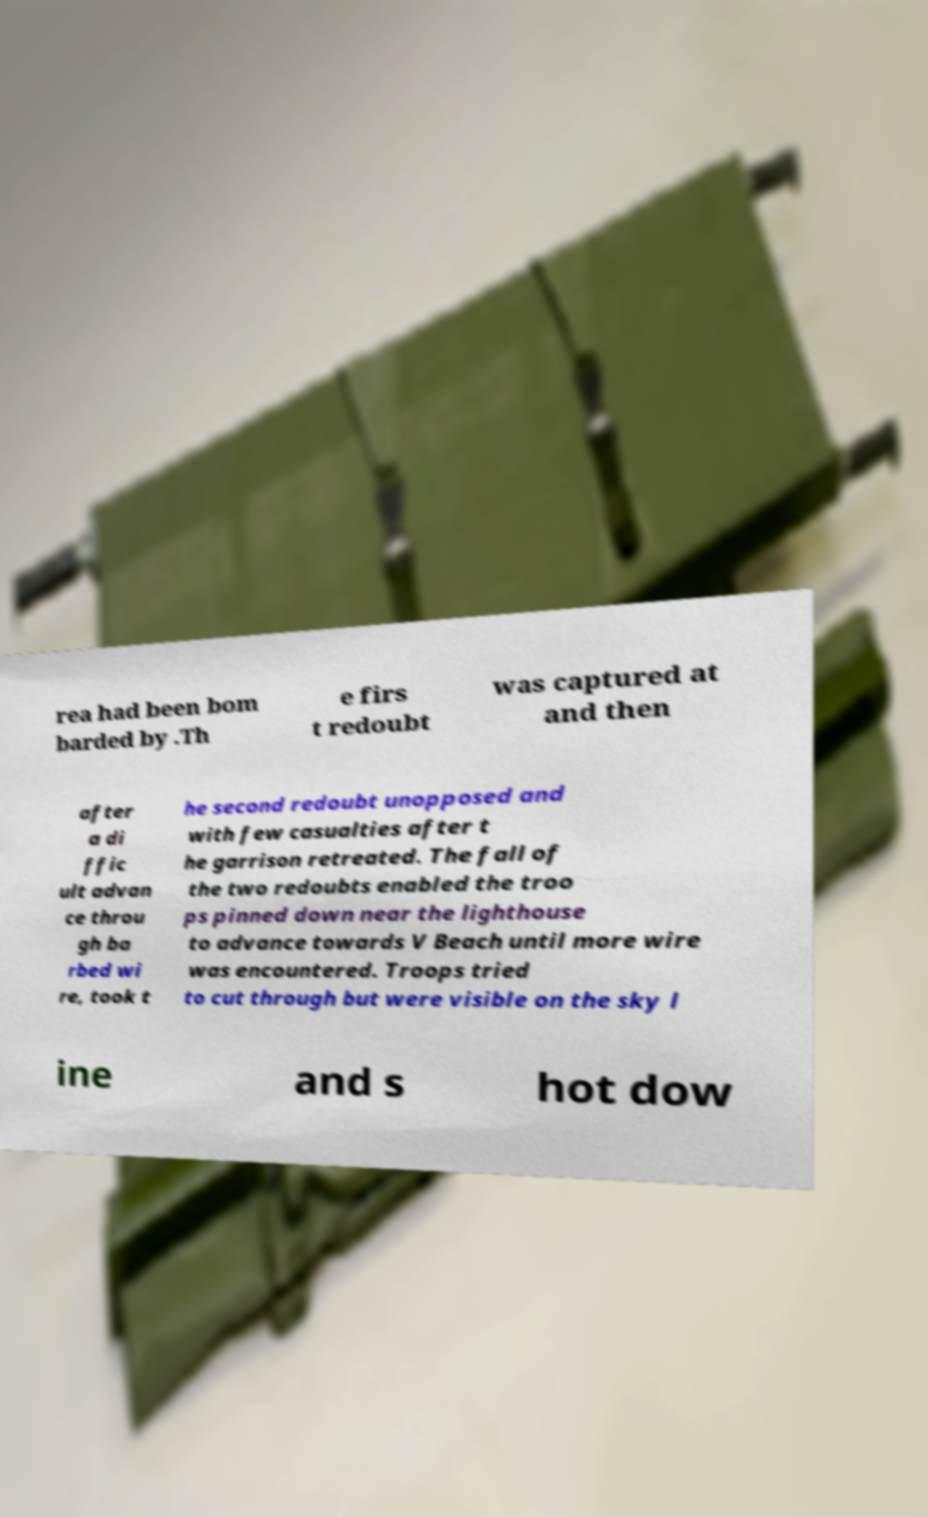Please read and relay the text visible in this image. What does it say? rea had been bom barded by .Th e firs t redoubt was captured at and then after a di ffic ult advan ce throu gh ba rbed wi re, took t he second redoubt unopposed and with few casualties after t he garrison retreated. The fall of the two redoubts enabled the troo ps pinned down near the lighthouse to advance towards V Beach until more wire was encountered. Troops tried to cut through but were visible on the sky l ine and s hot dow 